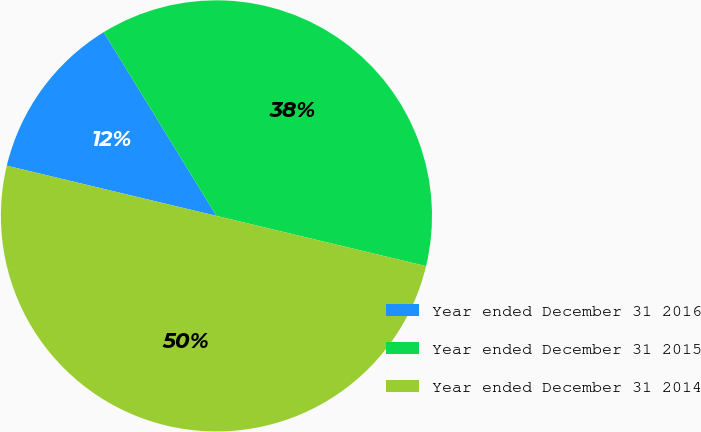Convert chart to OTSL. <chart><loc_0><loc_0><loc_500><loc_500><pie_chart><fcel>Year ended December 31 2016<fcel>Year ended December 31 2015<fcel>Year ended December 31 2014<nl><fcel>12.5%<fcel>37.5%<fcel>50.0%<nl></chart> 